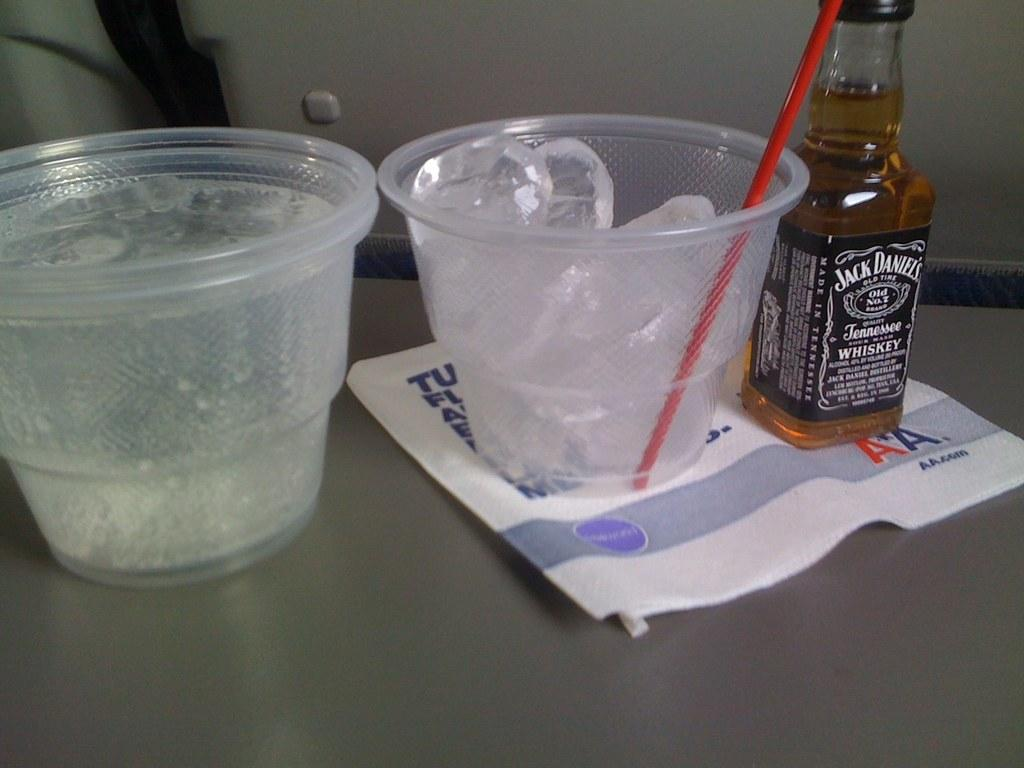<image>
Describe the image concisely. A minature bottle of Jack Daniels sits by a cup of ice. 